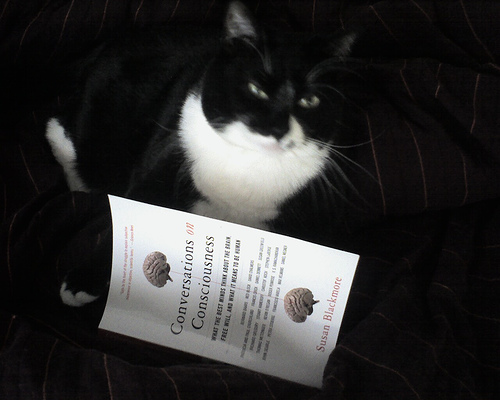Identify and read out the text in this image. Conversations Consciousness Susan on Blackmore 